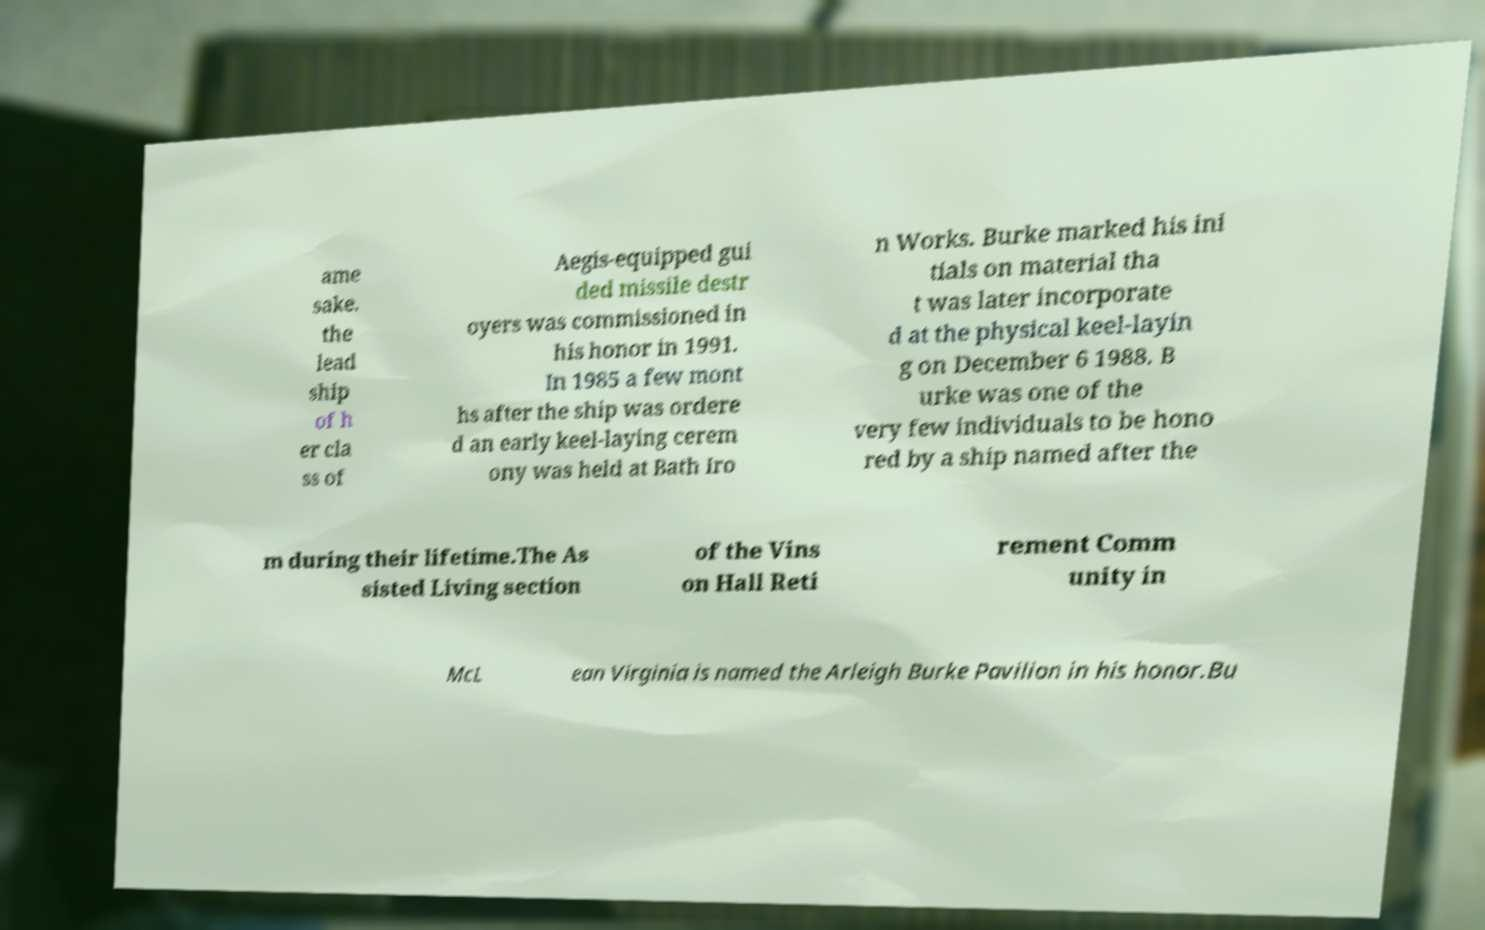Please identify and transcribe the text found in this image. ame sake. the lead ship of h er cla ss of Aegis-equipped gui ded missile destr oyers was commissioned in his honor in 1991. In 1985 a few mont hs after the ship was ordere d an early keel-laying cerem ony was held at Bath Iro n Works. Burke marked his ini tials on material tha t was later incorporate d at the physical keel-layin g on December 6 1988. B urke was one of the very few individuals to be hono red by a ship named after the m during their lifetime.The As sisted Living section of the Vins on Hall Reti rement Comm unity in McL ean Virginia is named the Arleigh Burke Pavilion in his honor.Bu 